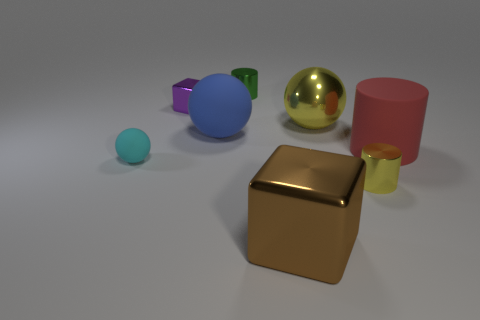Are there any tiny green metallic objects?
Your response must be concise. Yes. Is the number of cyan rubber balls that are on the right side of the purple shiny object less than the number of purple metal objects right of the green metal cylinder?
Provide a succinct answer. No. What shape is the matte thing on the right side of the yellow sphere?
Your answer should be very brief. Cylinder. Does the purple object have the same material as the large brown object?
Keep it short and to the point. Yes. Is there anything else that has the same material as the big red cylinder?
Your answer should be compact. Yes. There is a yellow thing that is the same shape as the red object; what is its material?
Keep it short and to the point. Metal. Are there fewer cyan matte things that are left of the cyan rubber thing than small purple shiny things?
Provide a short and direct response. Yes. What number of tiny metallic things are right of the purple metallic object?
Offer a very short reply. 2. There is a yellow metallic object that is in front of the big cylinder; does it have the same shape as the big blue matte thing behind the tiny matte object?
Keep it short and to the point. No. What is the shape of the small thing that is on the left side of the small yellow cylinder and in front of the tiny metal cube?
Offer a very short reply. Sphere. 